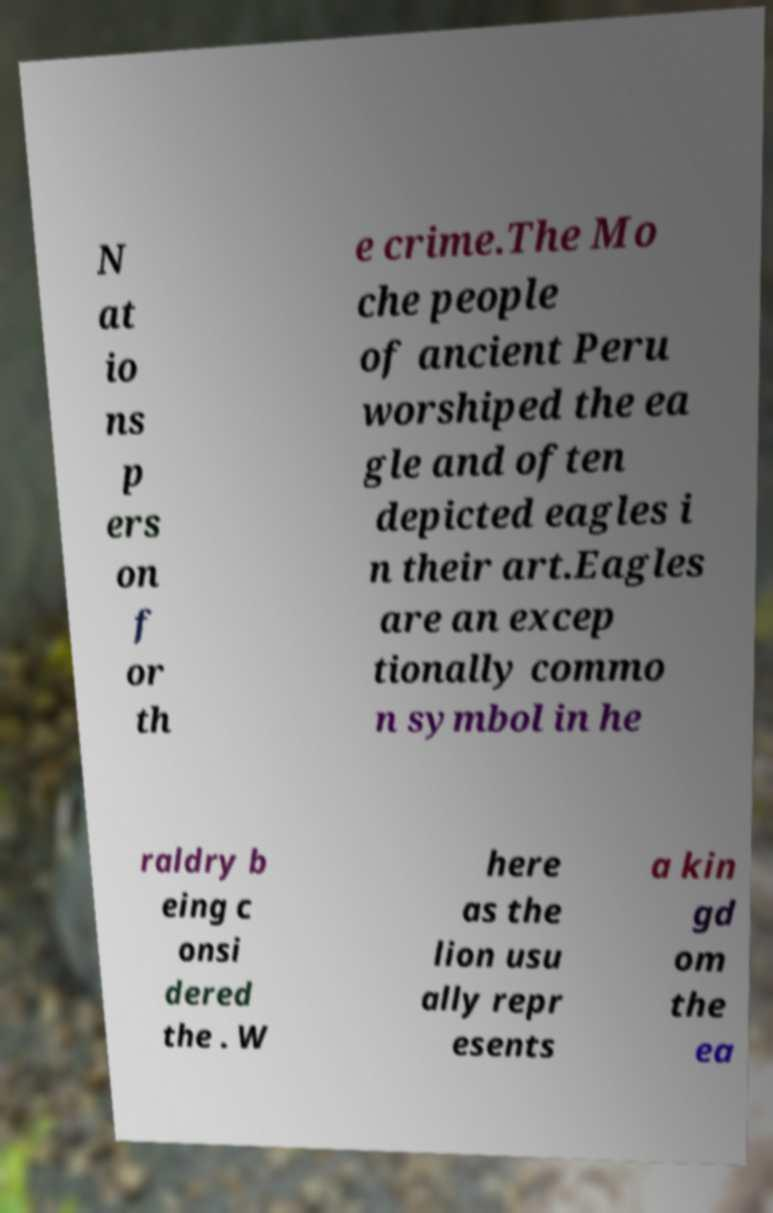Can you read and provide the text displayed in the image?This photo seems to have some interesting text. Can you extract and type it out for me? N at io ns p ers on f or th e crime.The Mo che people of ancient Peru worshiped the ea gle and often depicted eagles i n their art.Eagles are an excep tionally commo n symbol in he raldry b eing c onsi dered the . W here as the lion usu ally repr esents a kin gd om the ea 